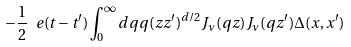<formula> <loc_0><loc_0><loc_500><loc_500>- \frac { 1 } { 2 } \ e ( t - t ^ { \prime } ) \int _ { 0 } ^ { \infty } d q q ( z z ^ { \prime } ) ^ { d / 2 } J _ { \nu } ( q z ) J _ { \nu } ( q z ^ { \prime } ) \Delta ( x , x ^ { \prime } )</formula> 